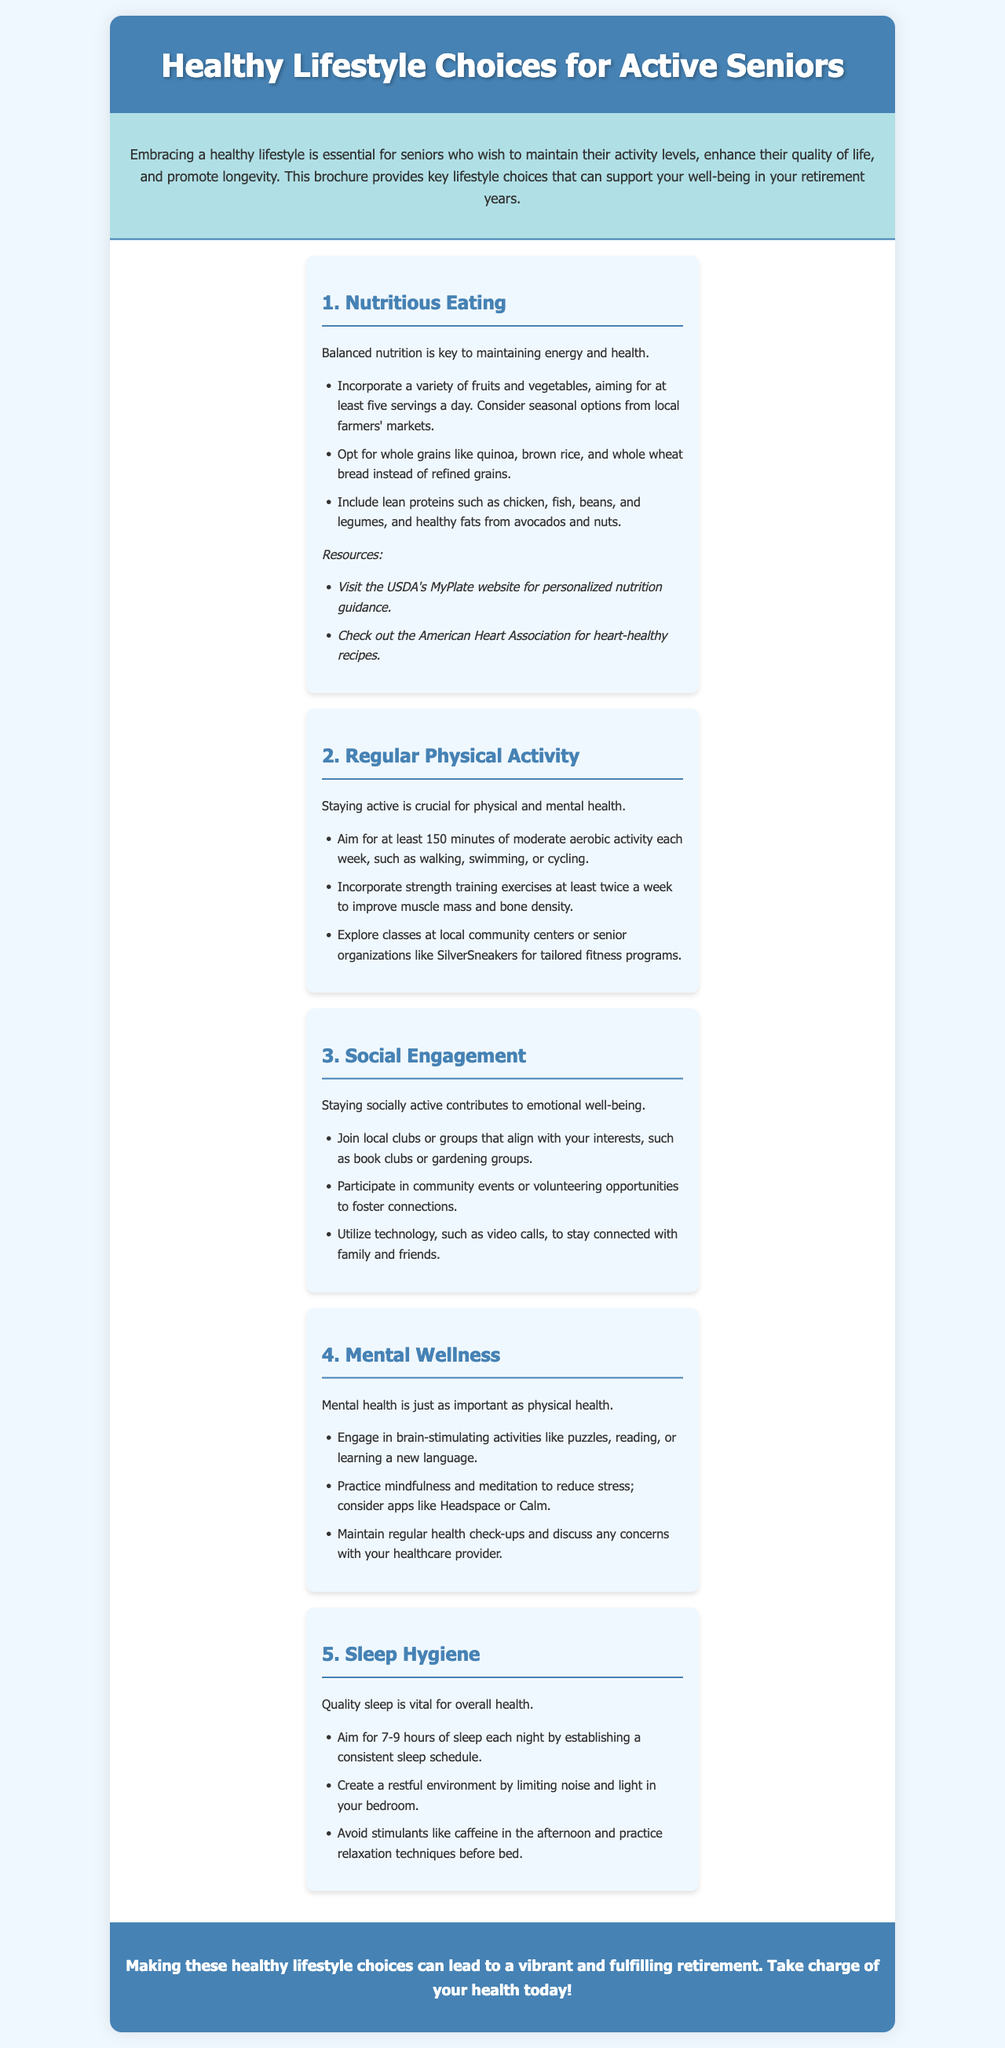What is the main topic of the brochure? The brochure focuses on healthy lifestyle choices specifically for active seniors.
Answer: Healthy Lifestyle Choices for Active Seniors How many servings of fruits and vegetables should seniors aim for daily? The document states that seniors should aim for at least five servings a day.
Answer: Five servings What types of grains should seniors prefer? The brochure advises opting for whole grains like quinoa, brown rice, and whole wheat bread.
Answer: Whole grains What is the recommended amount of exercise per week? The document recommends at least 150 minutes of moderate aerobic activity each week.
Answer: 150 minutes Which activity is suggested for mental wellness? Engaging in brain-stimulating activities like puzzles, reading, or learning a new language is advised.
Answer: Puzzles How often should strength training be performed? Strength training exercises should be incorporated at least twice a week.
Answer: Twice a week What is the importance of social engagement according to the brochure? Staying socially active contributes to emotional well-being.
Answer: Emotional well-being What are two relaxation techniques recommended before bed? The brochure suggests practicing relaxation techniques before bed and avoiding stimulants like caffeine in the afternoon.
Answer: Relaxation techniques Which organization is mentioned for heart-healthy recipes? The American Heart Association is referenced for heart-healthy recipes.
Answer: American Heart Association 